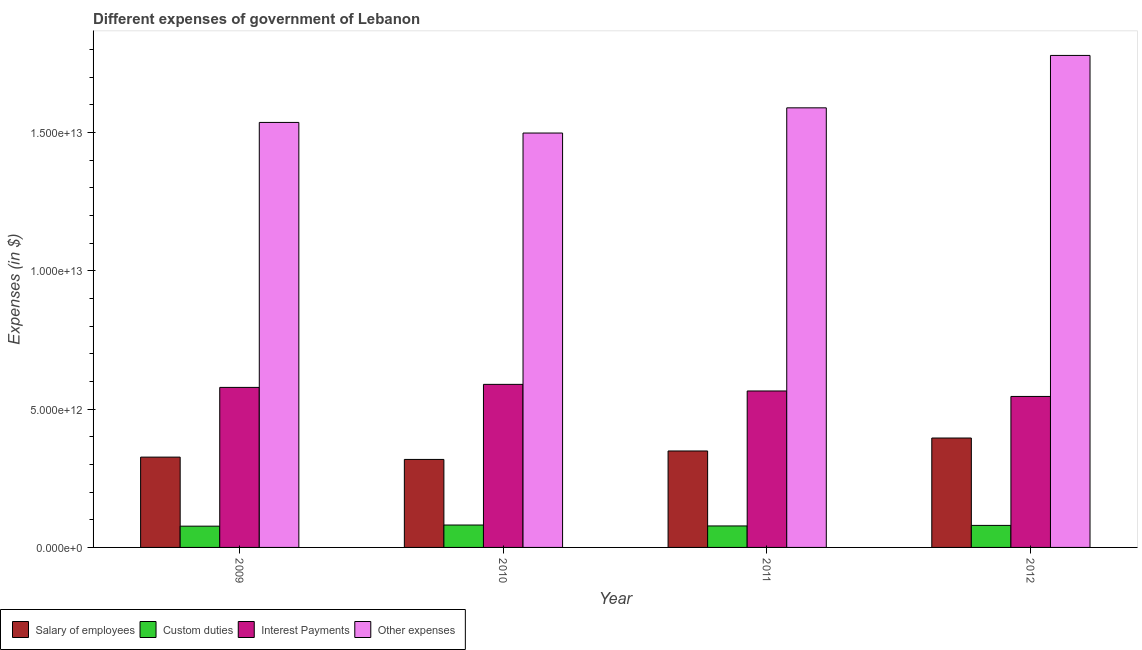Are the number of bars on each tick of the X-axis equal?
Your answer should be compact. Yes. What is the label of the 2nd group of bars from the left?
Your response must be concise. 2010. What is the amount spent on interest payments in 2010?
Offer a terse response. 5.89e+12. Across all years, what is the maximum amount spent on other expenses?
Your response must be concise. 1.78e+13. Across all years, what is the minimum amount spent on other expenses?
Your answer should be compact. 1.50e+13. In which year was the amount spent on other expenses maximum?
Provide a succinct answer. 2012. What is the total amount spent on other expenses in the graph?
Provide a short and direct response. 6.40e+13. What is the difference between the amount spent on other expenses in 2010 and that in 2011?
Your answer should be very brief. -9.11e+11. What is the difference between the amount spent on custom duties in 2012 and the amount spent on salary of employees in 2011?
Make the answer very short. 1.97e+1. What is the average amount spent on custom duties per year?
Keep it short and to the point. 7.88e+11. In the year 2010, what is the difference between the amount spent on other expenses and amount spent on interest payments?
Make the answer very short. 0. In how many years, is the amount spent on interest payments greater than 13000000000000 $?
Your answer should be compact. 0. What is the ratio of the amount spent on salary of employees in 2009 to that in 2011?
Your answer should be very brief. 0.94. Is the amount spent on other expenses in 2009 less than that in 2012?
Ensure brevity in your answer.  Yes. What is the difference between the highest and the second highest amount spent on interest payments?
Offer a terse response. 1.09e+11. What is the difference between the highest and the lowest amount spent on custom duties?
Your answer should be compact. 4.15e+1. In how many years, is the amount spent on other expenses greater than the average amount spent on other expenses taken over all years?
Your answer should be compact. 1. What does the 1st bar from the left in 2010 represents?
Your answer should be very brief. Salary of employees. What does the 2nd bar from the right in 2011 represents?
Make the answer very short. Interest Payments. How many bars are there?
Offer a terse response. 16. Are all the bars in the graph horizontal?
Make the answer very short. No. What is the difference between two consecutive major ticks on the Y-axis?
Your response must be concise. 5.00e+12. Does the graph contain grids?
Your response must be concise. No. How are the legend labels stacked?
Your answer should be compact. Horizontal. What is the title of the graph?
Your answer should be very brief. Different expenses of government of Lebanon. Does "Other Minerals" appear as one of the legend labels in the graph?
Give a very brief answer. No. What is the label or title of the X-axis?
Provide a short and direct response. Year. What is the label or title of the Y-axis?
Ensure brevity in your answer.  Expenses (in $). What is the Expenses (in $) of Salary of employees in 2009?
Make the answer very short. 3.26e+12. What is the Expenses (in $) of Custom duties in 2009?
Your answer should be very brief. 7.68e+11. What is the Expenses (in $) in Interest Payments in 2009?
Your answer should be compact. 5.78e+12. What is the Expenses (in $) of Other expenses in 2009?
Give a very brief answer. 1.54e+13. What is the Expenses (in $) of Salary of employees in 2010?
Provide a short and direct response. 3.18e+12. What is the Expenses (in $) of Custom duties in 2010?
Your answer should be very brief. 8.10e+11. What is the Expenses (in $) of Interest Payments in 2010?
Provide a succinct answer. 5.89e+12. What is the Expenses (in $) of Other expenses in 2010?
Your response must be concise. 1.50e+13. What is the Expenses (in $) of Salary of employees in 2011?
Your answer should be compact. 3.49e+12. What is the Expenses (in $) of Custom duties in 2011?
Your response must be concise. 7.77e+11. What is the Expenses (in $) in Interest Payments in 2011?
Provide a short and direct response. 5.65e+12. What is the Expenses (in $) in Other expenses in 2011?
Make the answer very short. 1.59e+13. What is the Expenses (in $) of Salary of employees in 2012?
Keep it short and to the point. 3.95e+12. What is the Expenses (in $) of Custom duties in 2012?
Your answer should be compact. 7.96e+11. What is the Expenses (in $) of Interest Payments in 2012?
Offer a very short reply. 5.46e+12. What is the Expenses (in $) in Other expenses in 2012?
Make the answer very short. 1.78e+13. Across all years, what is the maximum Expenses (in $) in Salary of employees?
Your response must be concise. 3.95e+12. Across all years, what is the maximum Expenses (in $) in Custom duties?
Your answer should be compact. 8.10e+11. Across all years, what is the maximum Expenses (in $) of Interest Payments?
Ensure brevity in your answer.  5.89e+12. Across all years, what is the maximum Expenses (in $) in Other expenses?
Keep it short and to the point. 1.78e+13. Across all years, what is the minimum Expenses (in $) of Salary of employees?
Ensure brevity in your answer.  3.18e+12. Across all years, what is the minimum Expenses (in $) of Custom duties?
Offer a very short reply. 7.68e+11. Across all years, what is the minimum Expenses (in $) of Interest Payments?
Provide a short and direct response. 5.46e+12. Across all years, what is the minimum Expenses (in $) of Other expenses?
Keep it short and to the point. 1.50e+13. What is the total Expenses (in $) of Salary of employees in the graph?
Ensure brevity in your answer.  1.39e+13. What is the total Expenses (in $) of Custom duties in the graph?
Make the answer very short. 3.15e+12. What is the total Expenses (in $) in Interest Payments in the graph?
Your answer should be compact. 2.28e+13. What is the total Expenses (in $) in Other expenses in the graph?
Provide a short and direct response. 6.40e+13. What is the difference between the Expenses (in $) in Salary of employees in 2009 and that in 2010?
Give a very brief answer. 8.34e+1. What is the difference between the Expenses (in $) in Custom duties in 2009 and that in 2010?
Make the answer very short. -4.15e+1. What is the difference between the Expenses (in $) in Interest Payments in 2009 and that in 2010?
Your answer should be very brief. -1.09e+11. What is the difference between the Expenses (in $) in Other expenses in 2009 and that in 2010?
Give a very brief answer. 3.84e+11. What is the difference between the Expenses (in $) in Salary of employees in 2009 and that in 2011?
Offer a terse response. -2.22e+11. What is the difference between the Expenses (in $) of Custom duties in 2009 and that in 2011?
Offer a very short reply. -8.39e+09. What is the difference between the Expenses (in $) in Interest Payments in 2009 and that in 2011?
Your answer should be very brief. 1.29e+11. What is the difference between the Expenses (in $) in Other expenses in 2009 and that in 2011?
Your answer should be compact. -5.27e+11. What is the difference between the Expenses (in $) of Salary of employees in 2009 and that in 2012?
Your response must be concise. -6.90e+11. What is the difference between the Expenses (in $) of Custom duties in 2009 and that in 2012?
Your answer should be compact. -2.80e+1. What is the difference between the Expenses (in $) in Interest Payments in 2009 and that in 2012?
Make the answer very short. 3.27e+11. What is the difference between the Expenses (in $) in Other expenses in 2009 and that in 2012?
Offer a terse response. -2.42e+12. What is the difference between the Expenses (in $) in Salary of employees in 2010 and that in 2011?
Offer a very short reply. -3.06e+11. What is the difference between the Expenses (in $) in Custom duties in 2010 and that in 2011?
Give a very brief answer. 3.31e+1. What is the difference between the Expenses (in $) in Interest Payments in 2010 and that in 2011?
Provide a succinct answer. 2.38e+11. What is the difference between the Expenses (in $) in Other expenses in 2010 and that in 2011?
Provide a succinct answer. -9.11e+11. What is the difference between the Expenses (in $) in Salary of employees in 2010 and that in 2012?
Your response must be concise. -7.74e+11. What is the difference between the Expenses (in $) of Custom duties in 2010 and that in 2012?
Your answer should be compact. 1.35e+1. What is the difference between the Expenses (in $) of Interest Payments in 2010 and that in 2012?
Ensure brevity in your answer.  4.36e+11. What is the difference between the Expenses (in $) in Other expenses in 2010 and that in 2012?
Offer a very short reply. -2.81e+12. What is the difference between the Expenses (in $) in Salary of employees in 2011 and that in 2012?
Offer a terse response. -4.68e+11. What is the difference between the Expenses (in $) in Custom duties in 2011 and that in 2012?
Your response must be concise. -1.97e+1. What is the difference between the Expenses (in $) in Interest Payments in 2011 and that in 2012?
Provide a succinct answer. 1.98e+11. What is the difference between the Expenses (in $) in Other expenses in 2011 and that in 2012?
Offer a terse response. -1.89e+12. What is the difference between the Expenses (in $) of Salary of employees in 2009 and the Expenses (in $) of Custom duties in 2010?
Offer a very short reply. 2.45e+12. What is the difference between the Expenses (in $) of Salary of employees in 2009 and the Expenses (in $) of Interest Payments in 2010?
Make the answer very short. -2.63e+12. What is the difference between the Expenses (in $) in Salary of employees in 2009 and the Expenses (in $) in Other expenses in 2010?
Your answer should be very brief. -1.17e+13. What is the difference between the Expenses (in $) in Custom duties in 2009 and the Expenses (in $) in Interest Payments in 2010?
Ensure brevity in your answer.  -5.13e+12. What is the difference between the Expenses (in $) in Custom duties in 2009 and the Expenses (in $) in Other expenses in 2010?
Your answer should be very brief. -1.42e+13. What is the difference between the Expenses (in $) of Interest Payments in 2009 and the Expenses (in $) of Other expenses in 2010?
Provide a short and direct response. -9.19e+12. What is the difference between the Expenses (in $) of Salary of employees in 2009 and the Expenses (in $) of Custom duties in 2011?
Offer a very short reply. 2.49e+12. What is the difference between the Expenses (in $) in Salary of employees in 2009 and the Expenses (in $) in Interest Payments in 2011?
Provide a short and direct response. -2.39e+12. What is the difference between the Expenses (in $) of Salary of employees in 2009 and the Expenses (in $) of Other expenses in 2011?
Provide a short and direct response. -1.26e+13. What is the difference between the Expenses (in $) in Custom duties in 2009 and the Expenses (in $) in Interest Payments in 2011?
Ensure brevity in your answer.  -4.89e+12. What is the difference between the Expenses (in $) of Custom duties in 2009 and the Expenses (in $) of Other expenses in 2011?
Your answer should be compact. -1.51e+13. What is the difference between the Expenses (in $) of Interest Payments in 2009 and the Expenses (in $) of Other expenses in 2011?
Your response must be concise. -1.01e+13. What is the difference between the Expenses (in $) in Salary of employees in 2009 and the Expenses (in $) in Custom duties in 2012?
Offer a very short reply. 2.47e+12. What is the difference between the Expenses (in $) of Salary of employees in 2009 and the Expenses (in $) of Interest Payments in 2012?
Offer a terse response. -2.19e+12. What is the difference between the Expenses (in $) of Salary of employees in 2009 and the Expenses (in $) of Other expenses in 2012?
Provide a short and direct response. -1.45e+13. What is the difference between the Expenses (in $) of Custom duties in 2009 and the Expenses (in $) of Interest Payments in 2012?
Ensure brevity in your answer.  -4.69e+12. What is the difference between the Expenses (in $) in Custom duties in 2009 and the Expenses (in $) in Other expenses in 2012?
Offer a terse response. -1.70e+13. What is the difference between the Expenses (in $) in Interest Payments in 2009 and the Expenses (in $) in Other expenses in 2012?
Make the answer very short. -1.20e+13. What is the difference between the Expenses (in $) of Salary of employees in 2010 and the Expenses (in $) of Custom duties in 2011?
Give a very brief answer. 2.40e+12. What is the difference between the Expenses (in $) of Salary of employees in 2010 and the Expenses (in $) of Interest Payments in 2011?
Offer a very short reply. -2.47e+12. What is the difference between the Expenses (in $) of Salary of employees in 2010 and the Expenses (in $) of Other expenses in 2011?
Ensure brevity in your answer.  -1.27e+13. What is the difference between the Expenses (in $) in Custom duties in 2010 and the Expenses (in $) in Interest Payments in 2011?
Make the answer very short. -4.85e+12. What is the difference between the Expenses (in $) of Custom duties in 2010 and the Expenses (in $) of Other expenses in 2011?
Offer a very short reply. -1.51e+13. What is the difference between the Expenses (in $) in Interest Payments in 2010 and the Expenses (in $) in Other expenses in 2011?
Make the answer very short. -1.00e+13. What is the difference between the Expenses (in $) in Salary of employees in 2010 and the Expenses (in $) in Custom duties in 2012?
Ensure brevity in your answer.  2.38e+12. What is the difference between the Expenses (in $) of Salary of employees in 2010 and the Expenses (in $) of Interest Payments in 2012?
Give a very brief answer. -2.28e+12. What is the difference between the Expenses (in $) in Salary of employees in 2010 and the Expenses (in $) in Other expenses in 2012?
Give a very brief answer. -1.46e+13. What is the difference between the Expenses (in $) in Custom duties in 2010 and the Expenses (in $) in Interest Payments in 2012?
Ensure brevity in your answer.  -4.65e+12. What is the difference between the Expenses (in $) in Custom duties in 2010 and the Expenses (in $) in Other expenses in 2012?
Your answer should be compact. -1.70e+13. What is the difference between the Expenses (in $) of Interest Payments in 2010 and the Expenses (in $) of Other expenses in 2012?
Your answer should be compact. -1.19e+13. What is the difference between the Expenses (in $) of Salary of employees in 2011 and the Expenses (in $) of Custom duties in 2012?
Your answer should be compact. 2.69e+12. What is the difference between the Expenses (in $) of Salary of employees in 2011 and the Expenses (in $) of Interest Payments in 2012?
Provide a succinct answer. -1.97e+12. What is the difference between the Expenses (in $) of Salary of employees in 2011 and the Expenses (in $) of Other expenses in 2012?
Offer a very short reply. -1.43e+13. What is the difference between the Expenses (in $) of Custom duties in 2011 and the Expenses (in $) of Interest Payments in 2012?
Make the answer very short. -4.68e+12. What is the difference between the Expenses (in $) of Custom duties in 2011 and the Expenses (in $) of Other expenses in 2012?
Your answer should be compact. -1.70e+13. What is the difference between the Expenses (in $) of Interest Payments in 2011 and the Expenses (in $) of Other expenses in 2012?
Provide a short and direct response. -1.21e+13. What is the average Expenses (in $) of Salary of employees per year?
Offer a very short reply. 3.47e+12. What is the average Expenses (in $) in Custom duties per year?
Your answer should be very brief. 7.88e+11. What is the average Expenses (in $) in Interest Payments per year?
Keep it short and to the point. 5.70e+12. What is the average Expenses (in $) in Other expenses per year?
Make the answer very short. 1.60e+13. In the year 2009, what is the difference between the Expenses (in $) in Salary of employees and Expenses (in $) in Custom duties?
Ensure brevity in your answer.  2.50e+12. In the year 2009, what is the difference between the Expenses (in $) in Salary of employees and Expenses (in $) in Interest Payments?
Provide a succinct answer. -2.52e+12. In the year 2009, what is the difference between the Expenses (in $) of Salary of employees and Expenses (in $) of Other expenses?
Provide a succinct answer. -1.21e+13. In the year 2009, what is the difference between the Expenses (in $) in Custom duties and Expenses (in $) in Interest Payments?
Give a very brief answer. -5.02e+12. In the year 2009, what is the difference between the Expenses (in $) of Custom duties and Expenses (in $) of Other expenses?
Give a very brief answer. -1.46e+13. In the year 2009, what is the difference between the Expenses (in $) in Interest Payments and Expenses (in $) in Other expenses?
Offer a terse response. -9.58e+12. In the year 2010, what is the difference between the Expenses (in $) of Salary of employees and Expenses (in $) of Custom duties?
Offer a very short reply. 2.37e+12. In the year 2010, what is the difference between the Expenses (in $) of Salary of employees and Expenses (in $) of Interest Payments?
Offer a terse response. -2.71e+12. In the year 2010, what is the difference between the Expenses (in $) of Salary of employees and Expenses (in $) of Other expenses?
Your answer should be very brief. -1.18e+13. In the year 2010, what is the difference between the Expenses (in $) in Custom duties and Expenses (in $) in Interest Payments?
Offer a terse response. -5.08e+12. In the year 2010, what is the difference between the Expenses (in $) of Custom duties and Expenses (in $) of Other expenses?
Offer a terse response. -1.42e+13. In the year 2010, what is the difference between the Expenses (in $) of Interest Payments and Expenses (in $) of Other expenses?
Provide a succinct answer. -9.08e+12. In the year 2011, what is the difference between the Expenses (in $) in Salary of employees and Expenses (in $) in Custom duties?
Your answer should be very brief. 2.71e+12. In the year 2011, what is the difference between the Expenses (in $) of Salary of employees and Expenses (in $) of Interest Payments?
Your response must be concise. -2.17e+12. In the year 2011, what is the difference between the Expenses (in $) of Salary of employees and Expenses (in $) of Other expenses?
Offer a very short reply. -1.24e+13. In the year 2011, what is the difference between the Expenses (in $) in Custom duties and Expenses (in $) in Interest Payments?
Ensure brevity in your answer.  -4.88e+12. In the year 2011, what is the difference between the Expenses (in $) in Custom duties and Expenses (in $) in Other expenses?
Provide a short and direct response. -1.51e+13. In the year 2011, what is the difference between the Expenses (in $) of Interest Payments and Expenses (in $) of Other expenses?
Offer a terse response. -1.02e+13. In the year 2012, what is the difference between the Expenses (in $) of Salary of employees and Expenses (in $) of Custom duties?
Your response must be concise. 3.16e+12. In the year 2012, what is the difference between the Expenses (in $) of Salary of employees and Expenses (in $) of Interest Payments?
Your response must be concise. -1.50e+12. In the year 2012, what is the difference between the Expenses (in $) of Salary of employees and Expenses (in $) of Other expenses?
Make the answer very short. -1.38e+13. In the year 2012, what is the difference between the Expenses (in $) of Custom duties and Expenses (in $) of Interest Payments?
Offer a terse response. -4.66e+12. In the year 2012, what is the difference between the Expenses (in $) of Custom duties and Expenses (in $) of Other expenses?
Offer a terse response. -1.70e+13. In the year 2012, what is the difference between the Expenses (in $) in Interest Payments and Expenses (in $) in Other expenses?
Make the answer very short. -1.23e+13. What is the ratio of the Expenses (in $) in Salary of employees in 2009 to that in 2010?
Provide a succinct answer. 1.03. What is the ratio of the Expenses (in $) of Custom duties in 2009 to that in 2010?
Provide a succinct answer. 0.95. What is the ratio of the Expenses (in $) in Interest Payments in 2009 to that in 2010?
Your answer should be compact. 0.98. What is the ratio of the Expenses (in $) in Other expenses in 2009 to that in 2010?
Offer a terse response. 1.03. What is the ratio of the Expenses (in $) of Salary of employees in 2009 to that in 2011?
Offer a very short reply. 0.94. What is the ratio of the Expenses (in $) of Custom duties in 2009 to that in 2011?
Give a very brief answer. 0.99. What is the ratio of the Expenses (in $) of Interest Payments in 2009 to that in 2011?
Ensure brevity in your answer.  1.02. What is the ratio of the Expenses (in $) in Other expenses in 2009 to that in 2011?
Offer a terse response. 0.97. What is the ratio of the Expenses (in $) of Salary of employees in 2009 to that in 2012?
Your response must be concise. 0.83. What is the ratio of the Expenses (in $) in Custom duties in 2009 to that in 2012?
Your answer should be very brief. 0.96. What is the ratio of the Expenses (in $) in Interest Payments in 2009 to that in 2012?
Offer a terse response. 1.06. What is the ratio of the Expenses (in $) in Other expenses in 2009 to that in 2012?
Keep it short and to the point. 0.86. What is the ratio of the Expenses (in $) of Salary of employees in 2010 to that in 2011?
Offer a very short reply. 0.91. What is the ratio of the Expenses (in $) of Custom duties in 2010 to that in 2011?
Your answer should be very brief. 1.04. What is the ratio of the Expenses (in $) of Interest Payments in 2010 to that in 2011?
Your answer should be compact. 1.04. What is the ratio of the Expenses (in $) in Other expenses in 2010 to that in 2011?
Make the answer very short. 0.94. What is the ratio of the Expenses (in $) in Salary of employees in 2010 to that in 2012?
Keep it short and to the point. 0.8. What is the ratio of the Expenses (in $) of Custom duties in 2010 to that in 2012?
Provide a succinct answer. 1.02. What is the ratio of the Expenses (in $) in Interest Payments in 2010 to that in 2012?
Offer a very short reply. 1.08. What is the ratio of the Expenses (in $) in Other expenses in 2010 to that in 2012?
Provide a short and direct response. 0.84. What is the ratio of the Expenses (in $) of Salary of employees in 2011 to that in 2012?
Keep it short and to the point. 0.88. What is the ratio of the Expenses (in $) in Custom duties in 2011 to that in 2012?
Provide a short and direct response. 0.98. What is the ratio of the Expenses (in $) in Interest Payments in 2011 to that in 2012?
Ensure brevity in your answer.  1.04. What is the ratio of the Expenses (in $) in Other expenses in 2011 to that in 2012?
Make the answer very short. 0.89. What is the difference between the highest and the second highest Expenses (in $) of Salary of employees?
Your answer should be compact. 4.68e+11. What is the difference between the highest and the second highest Expenses (in $) in Custom duties?
Ensure brevity in your answer.  1.35e+1. What is the difference between the highest and the second highest Expenses (in $) of Interest Payments?
Offer a terse response. 1.09e+11. What is the difference between the highest and the second highest Expenses (in $) of Other expenses?
Provide a succinct answer. 1.89e+12. What is the difference between the highest and the lowest Expenses (in $) of Salary of employees?
Keep it short and to the point. 7.74e+11. What is the difference between the highest and the lowest Expenses (in $) of Custom duties?
Offer a very short reply. 4.15e+1. What is the difference between the highest and the lowest Expenses (in $) in Interest Payments?
Provide a succinct answer. 4.36e+11. What is the difference between the highest and the lowest Expenses (in $) of Other expenses?
Ensure brevity in your answer.  2.81e+12. 